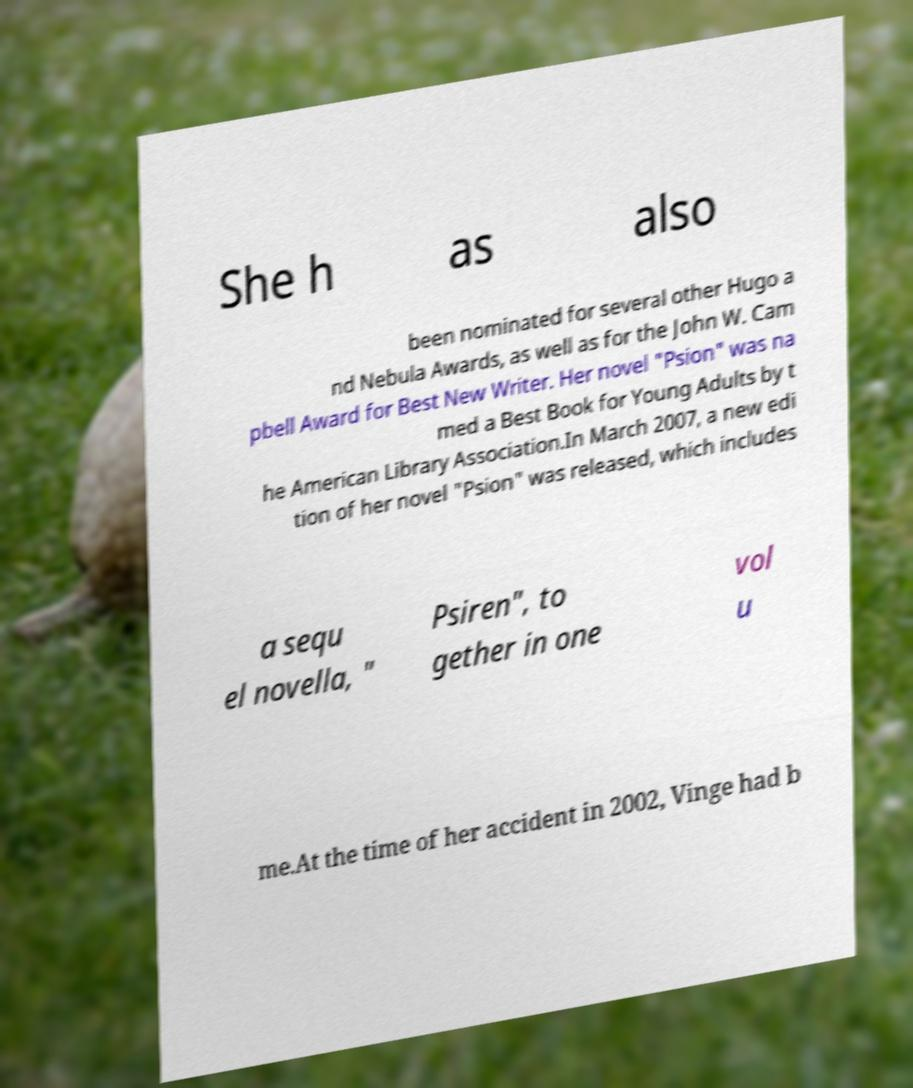There's text embedded in this image that I need extracted. Can you transcribe it verbatim? She h as also been nominated for several other Hugo a nd Nebula Awards, as well as for the John W. Cam pbell Award for Best New Writer. Her novel "Psion" was na med a Best Book for Young Adults by t he American Library Association.In March 2007, a new edi tion of her novel "Psion" was released, which includes a sequ el novella, " Psiren", to gether in one vol u me.At the time of her accident in 2002, Vinge had b 